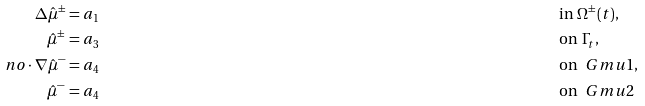Convert formula to latex. <formula><loc_0><loc_0><loc_500><loc_500>\Delta \hat { \mu } ^ { \pm } & = a _ { 1 } & & \text {in } \Omega ^ { \pm } ( t ) , \\ \hat { \mu } ^ { \pm } & = a _ { 3 } & & \text {on } \Gamma _ { t } , \\ \ n o \cdot \nabla \hat { \mu } ^ { - } & = a _ { 4 } & & \text {on } \ G m u { 1 } , \\ \hat { \mu } ^ { - } & = a _ { 4 } & & \text {on } \ G m u { 2 }</formula> 